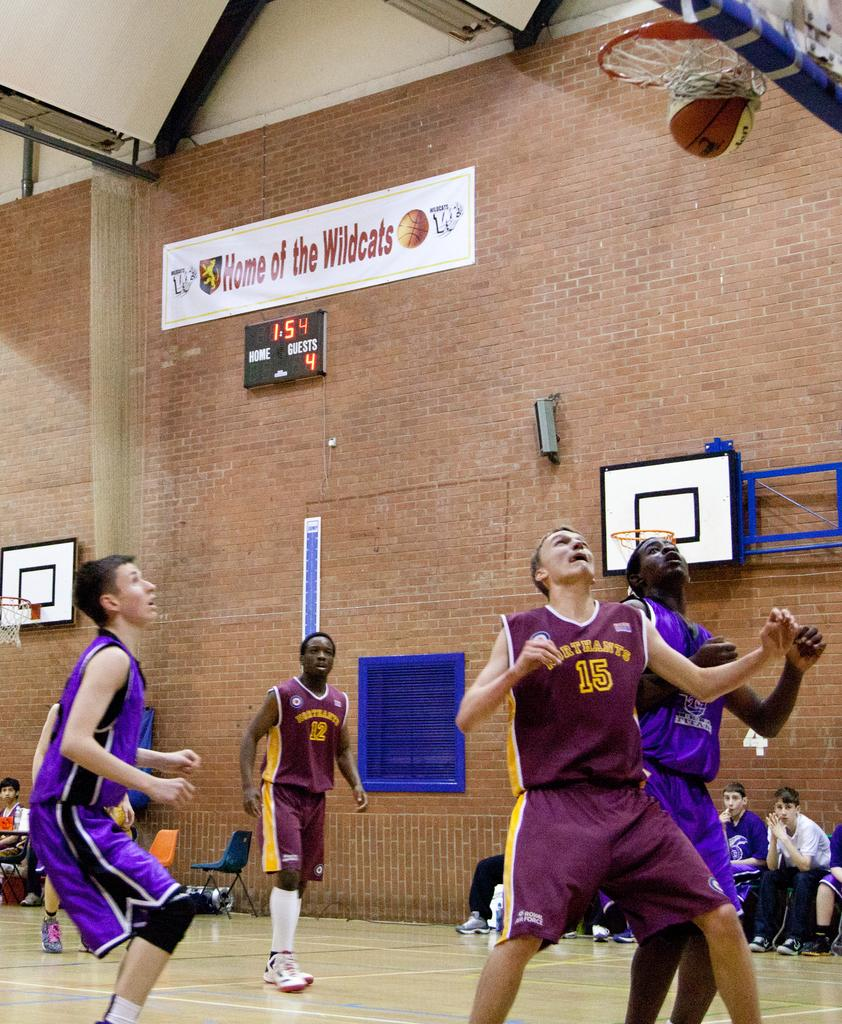Provide a one-sentence caption for the provided image. A player in a maroon shirt with the number 15 on it waiting for the ball. 